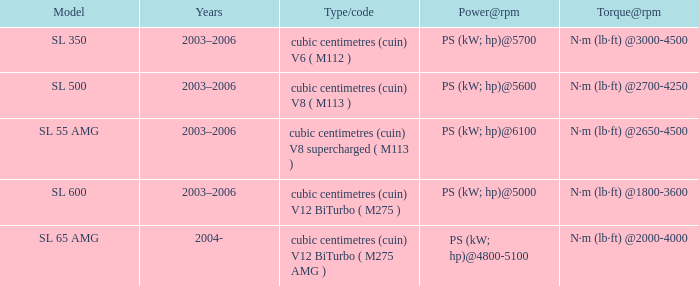What year was the SL 350 Model? 2003–2006. 